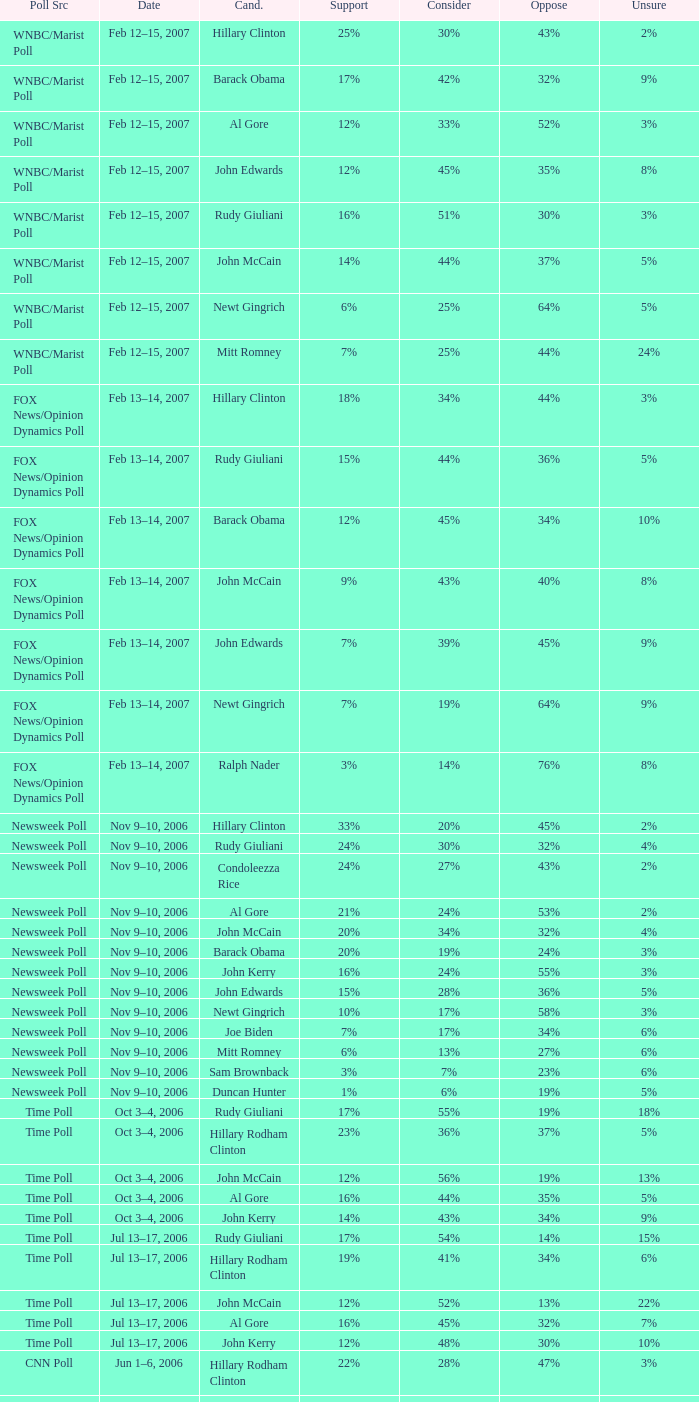What percentage of people were opposed to the candidate based on the WNBC/Marist poll that showed 8% of people were unsure? 35%. 